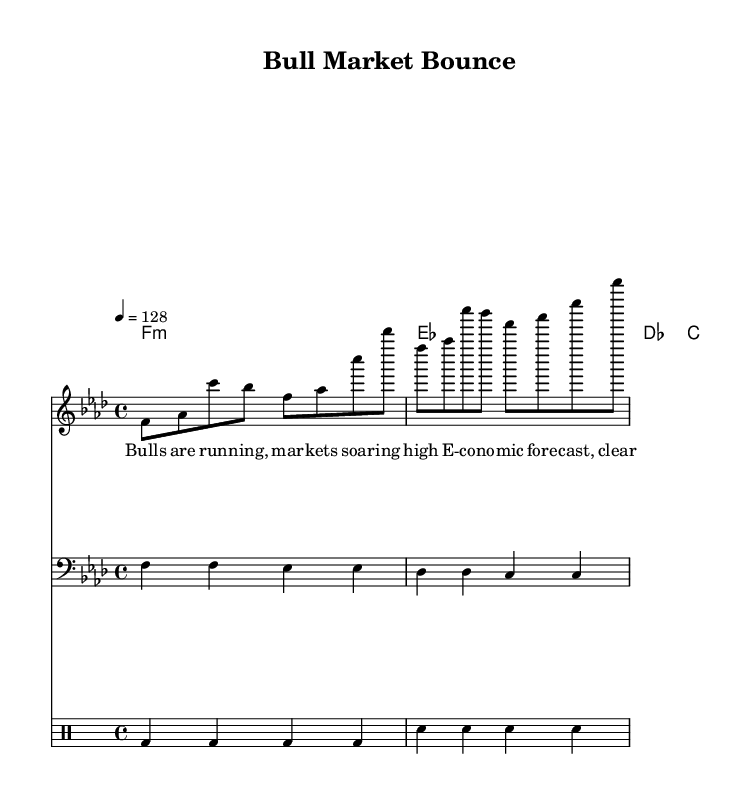What is the key signature of this music? The key signature can be identified by looking at the beginning of the staff, where there are four flats. This indicates that the piece is in F minor.
Answer: F minor What is the time signature of this music? The time signature is found at the beginning of the score, where it shows a 4 over 4; this means there are four beats per measure and a quarter note gets one beat.
Answer: 4/4 What is the tempo marking in this music? The tempo marking is indicated in the score where it states "4 = 128," showing that there are 128 beats per minute.
Answer: 128 What type of chords are being used in this piece? The chord names indicate the quality of the chords. The first chord listed is F minor, followed by E flat major, D flat major, and C major. These are major and minor chords typical in house music.
Answer: F minor, E flat major, D flat major, C major What is the role of the bass in this arrangement? The bass voice plays a foundational role, providing a rhythmic and harmonic backbone for the house piece. The bass notes are focused on maintaining a steady pulse and complementing the chords.
Answer: Foundation What type of lyrics are featured in this song? The lyrics reflect themes relevant to financial markets and economic forecasting, making it a unique fusion of house music with economic concepts. It talks about bullish trends in markets and forecasts related to the Egyptian economy.
Answer: Economic themes How does the drum pattern support the overall style of House music? In the drum section, the consistent bass drum hits and snare placement create a driving rhythm typical in house music, helping to establish an energetic dance feel throughout the piece.
Answer: Driving rhythm 